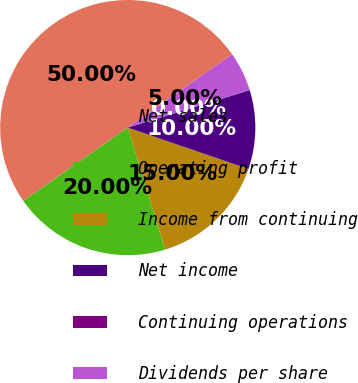Convert chart. <chart><loc_0><loc_0><loc_500><loc_500><pie_chart><fcel>Net sales<fcel>Operating profit<fcel>Income from continuing<fcel>Net income<fcel>Continuing operations<fcel>Dividends per share<nl><fcel>50.0%<fcel>20.0%<fcel>15.0%<fcel>10.0%<fcel>0.0%<fcel>5.0%<nl></chart> 